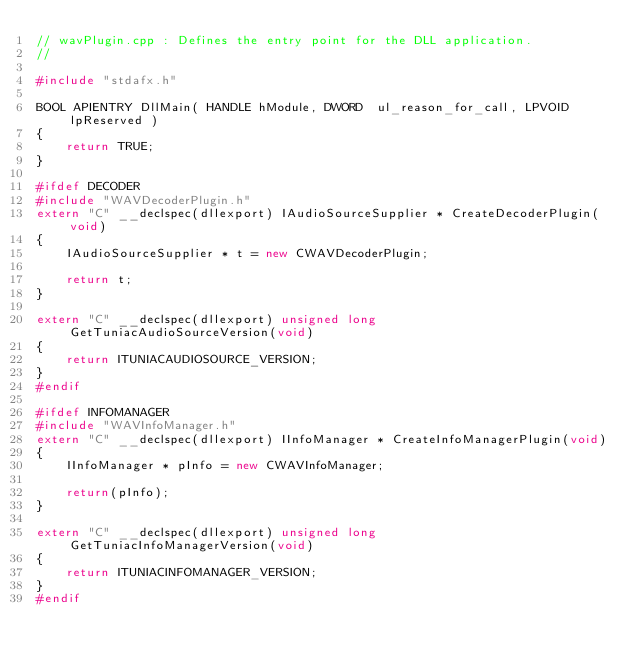Convert code to text. <code><loc_0><loc_0><loc_500><loc_500><_C++_>// wavPlugin.cpp : Defines the entry point for the DLL application.
//

#include "stdafx.h"

BOOL APIENTRY DllMain( HANDLE hModule, DWORD  ul_reason_for_call, LPVOID lpReserved )
{
    return TRUE;
}

#ifdef DECODER
#include "WAVDecoderPlugin.h"
extern "C" __declspec(dllexport) IAudioSourceSupplier * CreateDecoderPlugin(void)
{
	IAudioSourceSupplier * t = new CWAVDecoderPlugin;

	return t;
}

extern "C" __declspec(dllexport) unsigned long		GetTuniacAudioSourceVersion(void)
{
	return ITUNIACAUDIOSOURCE_VERSION;
}
#endif

#ifdef INFOMANAGER
#include "WAVInfoManager.h"
extern "C" __declspec(dllexport) IInfoManager * CreateInfoManagerPlugin(void)
{
	IInfoManager * pInfo = new CWAVInfoManager;

	return(pInfo);
}

extern "C" __declspec(dllexport) unsigned long		GetTuniacInfoManagerVersion(void)
{
	return ITUNIACINFOMANAGER_VERSION;
}
#endif</code> 